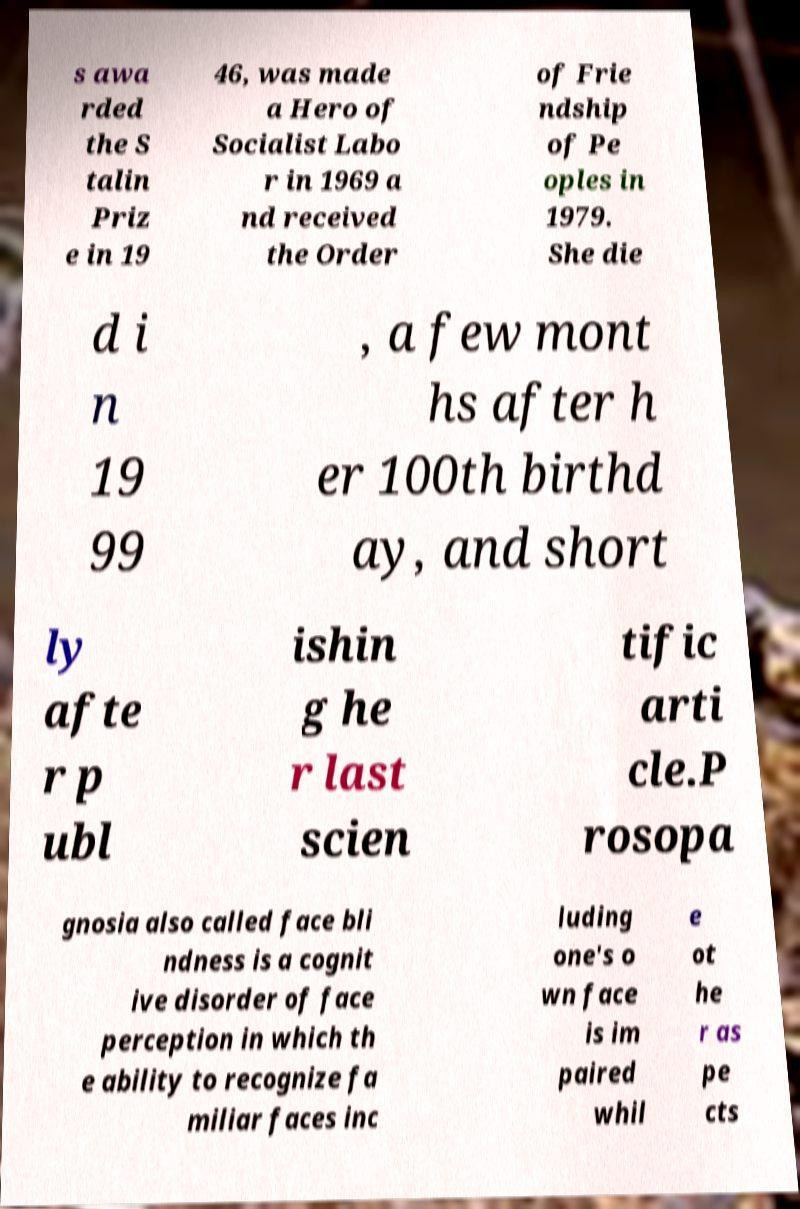Can you accurately transcribe the text from the provided image for me? s awa rded the S talin Priz e in 19 46, was made a Hero of Socialist Labo r in 1969 a nd received the Order of Frie ndship of Pe oples in 1979. She die d i n 19 99 , a few mont hs after h er 100th birthd ay, and short ly afte r p ubl ishin g he r last scien tific arti cle.P rosopa gnosia also called face bli ndness is a cognit ive disorder of face perception in which th e ability to recognize fa miliar faces inc luding one's o wn face is im paired whil e ot he r as pe cts 